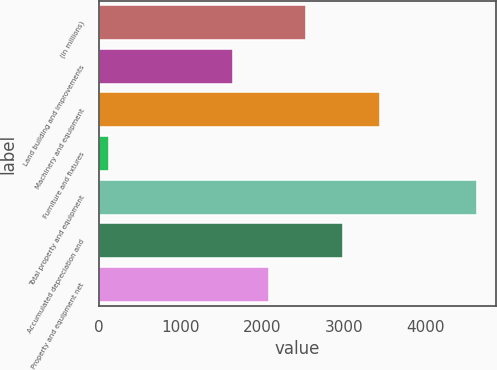<chart> <loc_0><loc_0><loc_500><loc_500><bar_chart><fcel>(in millions)<fcel>Land building and improvements<fcel>Machinery and equipment<fcel>Furniture and fixtures<fcel>Total property and equipment<fcel>Accumulated depreciation and<fcel>Property and equipment net<nl><fcel>2536.4<fcel>1637<fcel>3435.8<fcel>130<fcel>4627<fcel>2986.1<fcel>2086.7<nl></chart> 